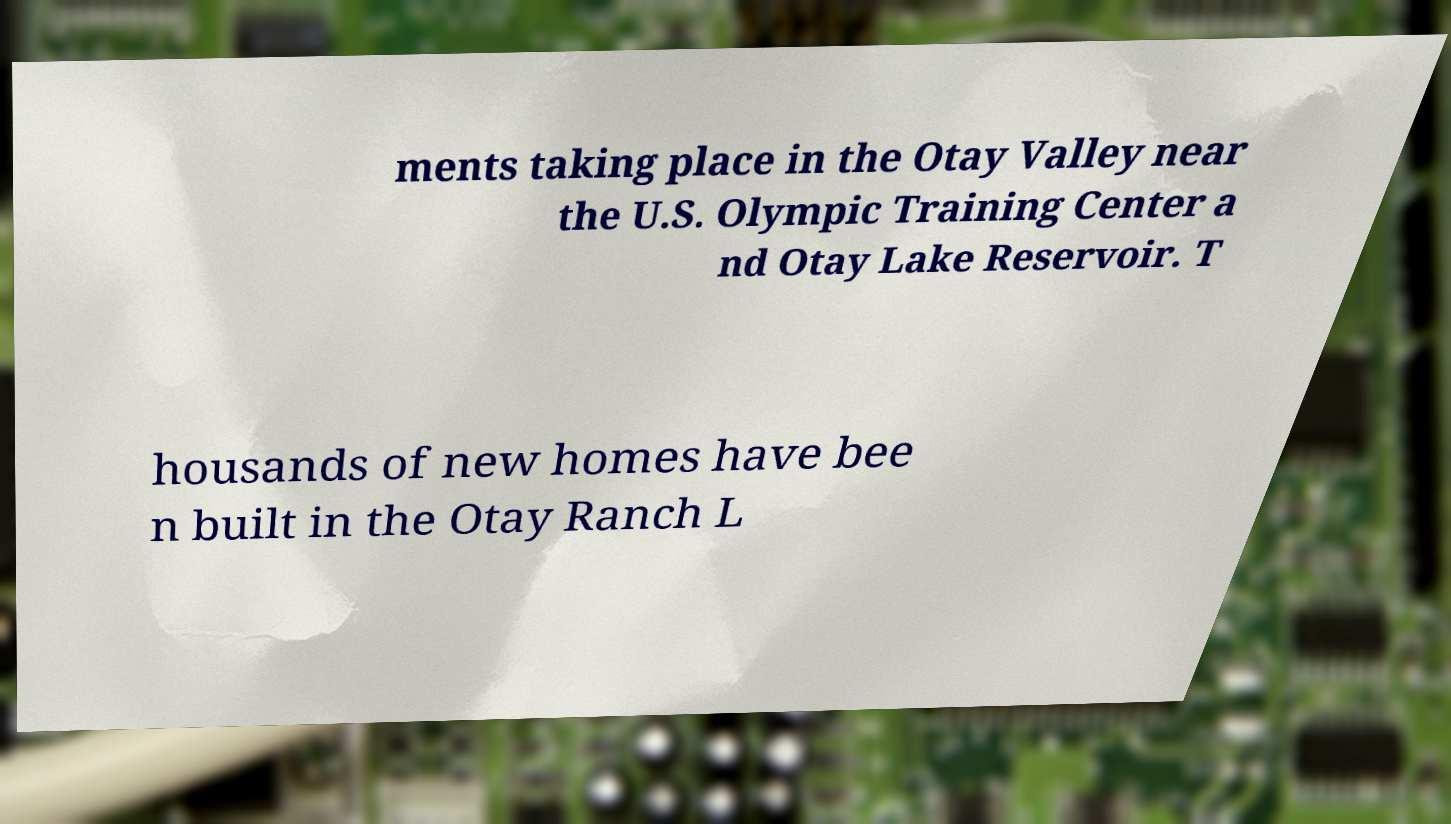Can you read and provide the text displayed in the image?This photo seems to have some interesting text. Can you extract and type it out for me? ments taking place in the Otay Valley near the U.S. Olympic Training Center a nd Otay Lake Reservoir. T housands of new homes have bee n built in the Otay Ranch L 